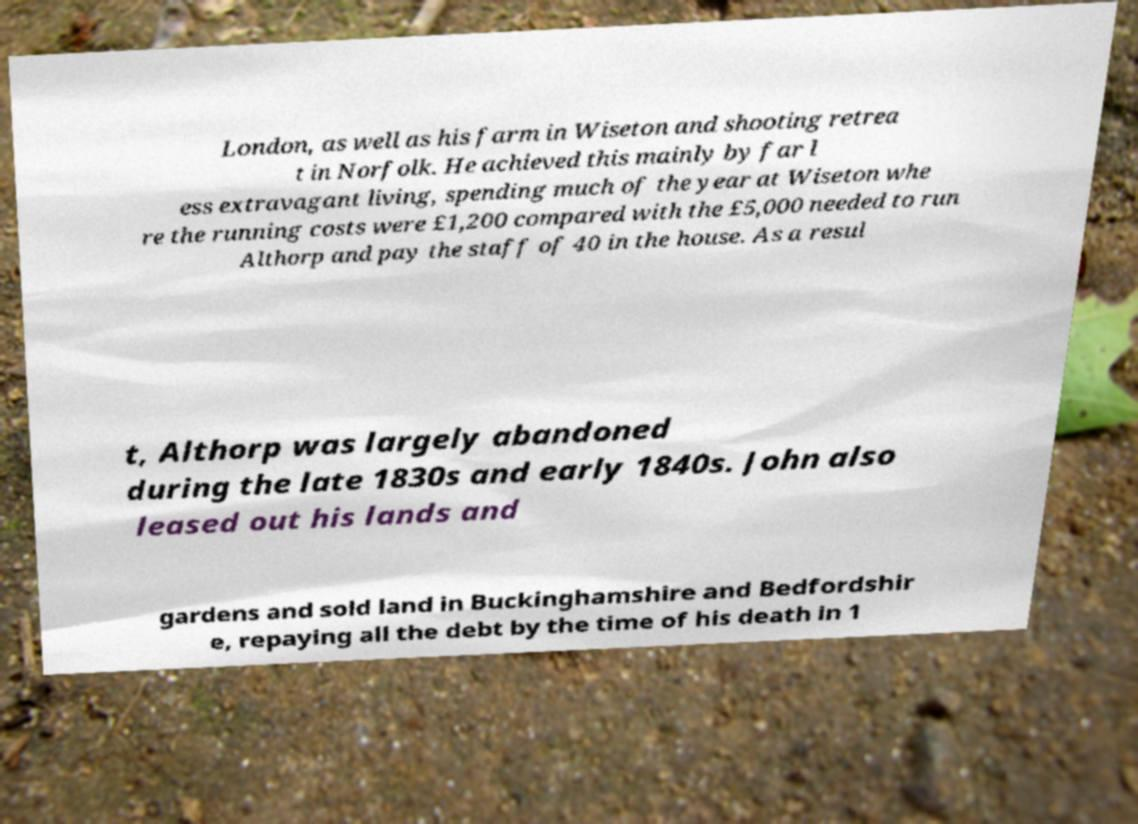What messages or text are displayed in this image? I need them in a readable, typed format. London, as well as his farm in Wiseton and shooting retrea t in Norfolk. He achieved this mainly by far l ess extravagant living, spending much of the year at Wiseton whe re the running costs were £1,200 compared with the £5,000 needed to run Althorp and pay the staff of 40 in the house. As a resul t, Althorp was largely abandoned during the late 1830s and early 1840s. John also leased out his lands and gardens and sold land in Buckinghamshire and Bedfordshir e, repaying all the debt by the time of his death in 1 